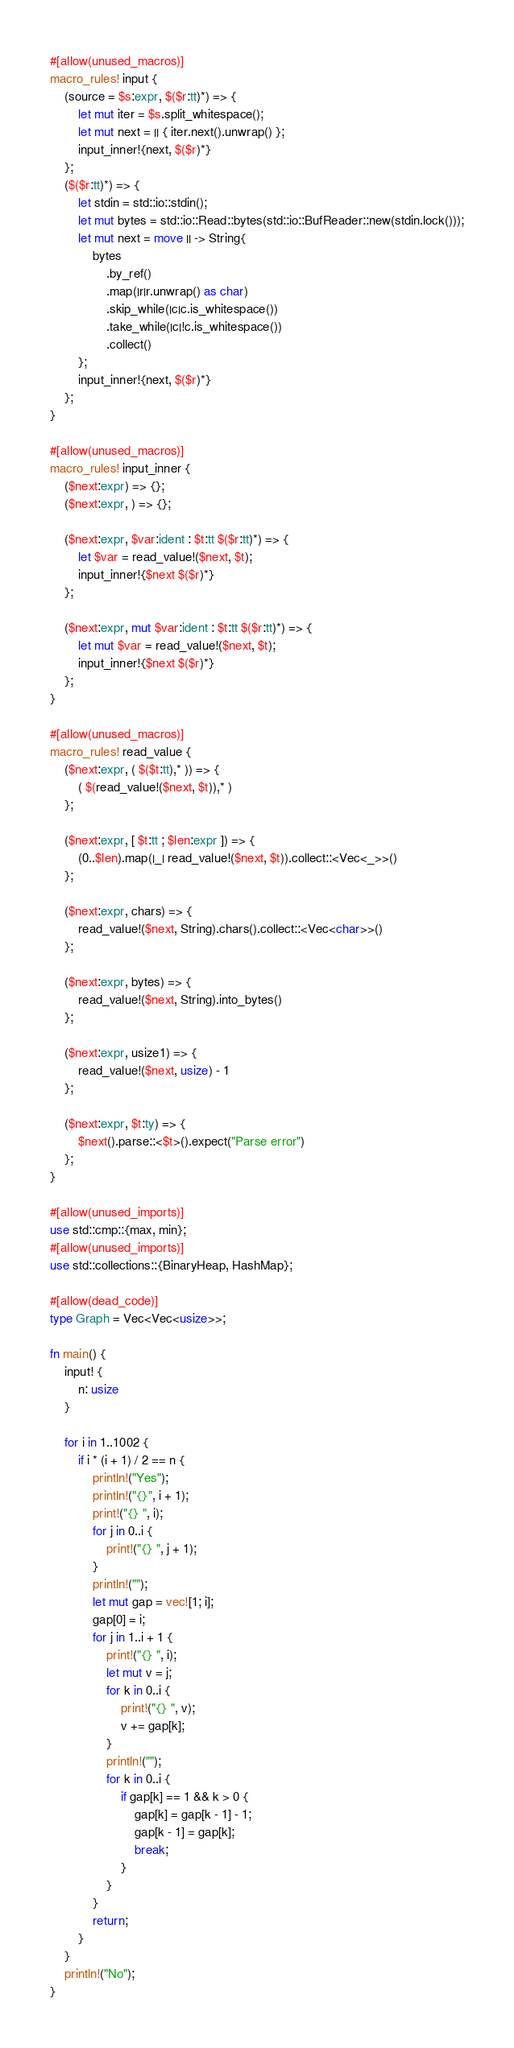<code> <loc_0><loc_0><loc_500><loc_500><_Rust_>#[allow(unused_macros)]
macro_rules! input {
    (source = $s:expr, $($r:tt)*) => {
        let mut iter = $s.split_whitespace();
        let mut next = || { iter.next().unwrap() };
        input_inner!{next, $($r)*}
    };
    ($($r:tt)*) => {
        let stdin = std::io::stdin();
        let mut bytes = std::io::Read::bytes(std::io::BufReader::new(stdin.lock()));
        let mut next = move || -> String{
            bytes
                .by_ref()
                .map(|r|r.unwrap() as char)
                .skip_while(|c|c.is_whitespace())
                .take_while(|c|!c.is_whitespace())
                .collect()
        };
        input_inner!{next, $($r)*}
    };
}

#[allow(unused_macros)]
macro_rules! input_inner {
    ($next:expr) => {};
    ($next:expr, ) => {};

    ($next:expr, $var:ident : $t:tt $($r:tt)*) => {
        let $var = read_value!($next, $t);
        input_inner!{$next $($r)*}
    };

    ($next:expr, mut $var:ident : $t:tt $($r:tt)*) => {
        let mut $var = read_value!($next, $t);
        input_inner!{$next $($r)*}
    };
}

#[allow(unused_macros)]
macro_rules! read_value {
    ($next:expr, ( $($t:tt),* )) => {
        ( $(read_value!($next, $t)),* )
    };

    ($next:expr, [ $t:tt ; $len:expr ]) => {
        (0..$len).map(|_| read_value!($next, $t)).collect::<Vec<_>>()
    };

    ($next:expr, chars) => {
        read_value!($next, String).chars().collect::<Vec<char>>()
    };

    ($next:expr, bytes) => {
        read_value!($next, String).into_bytes()
    };

    ($next:expr, usize1) => {
        read_value!($next, usize) - 1
    };

    ($next:expr, $t:ty) => {
        $next().parse::<$t>().expect("Parse error")
    };
}

#[allow(unused_imports)]
use std::cmp::{max, min};
#[allow(unused_imports)]
use std::collections::{BinaryHeap, HashMap};

#[allow(dead_code)]
type Graph = Vec<Vec<usize>>;

fn main() {
    input! {
        n: usize
    }

    for i in 1..1002 {
        if i * (i + 1) / 2 == n {
            println!("Yes");
            println!("{}", i + 1);
            print!("{} ", i);
            for j in 0..i {
                print!("{} ", j + 1);
            }
            println!("");
            let mut gap = vec![1; i];
            gap[0] = i;
            for j in 1..i + 1 {
                print!("{} ", i);
                let mut v = j;
                for k in 0..i {
                    print!("{} ", v);
                    v += gap[k];
                }
                println!("");
                for k in 0..i {
                    if gap[k] == 1 && k > 0 {
                        gap[k] = gap[k - 1] - 1;
                        gap[k - 1] = gap[k];
                        break;
                    }
                }
            }
            return;
        }
    }
    println!("No");
}
</code> 